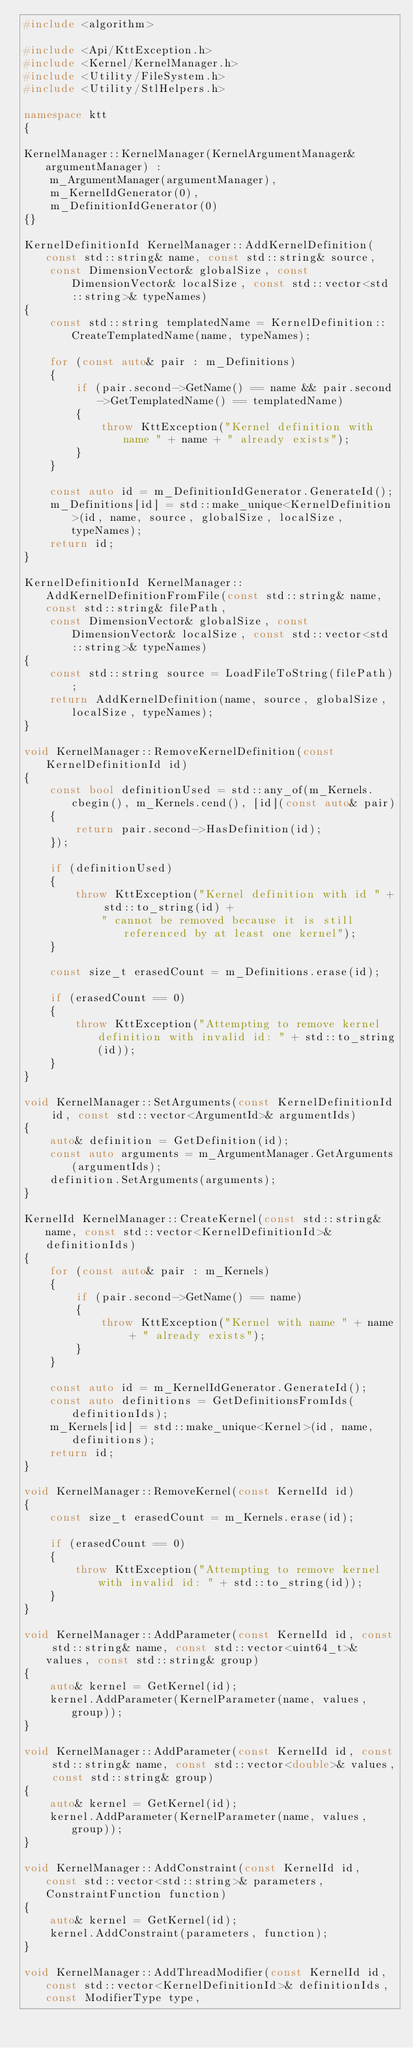Convert code to text. <code><loc_0><loc_0><loc_500><loc_500><_C++_>#include <algorithm>

#include <Api/KttException.h>
#include <Kernel/KernelManager.h>
#include <Utility/FileSystem.h>
#include <Utility/StlHelpers.h>

namespace ktt
{

KernelManager::KernelManager(KernelArgumentManager& argumentManager) :
    m_ArgumentManager(argumentManager),
    m_KernelIdGenerator(0),
    m_DefinitionIdGenerator(0)
{}

KernelDefinitionId KernelManager::AddKernelDefinition(const std::string& name, const std::string& source,
    const DimensionVector& globalSize, const DimensionVector& localSize, const std::vector<std::string>& typeNames)
{
    const std::string templatedName = KernelDefinition::CreateTemplatedName(name, typeNames);

    for (const auto& pair : m_Definitions)
    {
        if (pair.second->GetName() == name && pair.second->GetTemplatedName() == templatedName)
        {
            throw KttException("Kernel definition with name " + name + " already exists");
        }
    }

    const auto id = m_DefinitionIdGenerator.GenerateId();
    m_Definitions[id] = std::make_unique<KernelDefinition>(id, name, source, globalSize, localSize, typeNames);
    return id;
}

KernelDefinitionId KernelManager::AddKernelDefinitionFromFile(const std::string& name, const std::string& filePath,
    const DimensionVector& globalSize, const DimensionVector& localSize, const std::vector<std::string>& typeNames)
{
    const std::string source = LoadFileToString(filePath);
    return AddKernelDefinition(name, source, globalSize, localSize, typeNames);
}

void KernelManager::RemoveKernelDefinition(const KernelDefinitionId id)
{
    const bool definitionUsed = std::any_of(m_Kernels.cbegin(), m_Kernels.cend(), [id](const auto& pair)
    {
        return pair.second->HasDefinition(id);
    });

    if (definitionUsed)
    {
        throw KttException("Kernel definition with id " + std::to_string(id) +
            " cannot be removed because it is still referenced by at least one kernel");
    }

    const size_t erasedCount = m_Definitions.erase(id);

    if (erasedCount == 0)
    {
        throw KttException("Attempting to remove kernel definition with invalid id: " + std::to_string(id));
    }
}

void KernelManager::SetArguments(const KernelDefinitionId id, const std::vector<ArgumentId>& argumentIds)
{
    auto& definition = GetDefinition(id);
    const auto arguments = m_ArgumentManager.GetArguments(argumentIds);
    definition.SetArguments(arguments);
}

KernelId KernelManager::CreateKernel(const std::string& name, const std::vector<KernelDefinitionId>& definitionIds)
{
    for (const auto& pair : m_Kernels)
    {
        if (pair.second->GetName() == name)
        {
            throw KttException("Kernel with name " + name + " already exists");
        }
    }

    const auto id = m_KernelIdGenerator.GenerateId();
    const auto definitions = GetDefinitionsFromIds(definitionIds);
    m_Kernels[id] = std::make_unique<Kernel>(id, name, definitions);
    return id;
}

void KernelManager::RemoveKernel(const KernelId id)
{
    const size_t erasedCount = m_Kernels.erase(id);

    if (erasedCount == 0)
    {
        throw KttException("Attempting to remove kernel with invalid id: " + std::to_string(id));
    }
}

void KernelManager::AddParameter(const KernelId id, const std::string& name, const std::vector<uint64_t>& values, const std::string& group)
{
    auto& kernel = GetKernel(id);
    kernel.AddParameter(KernelParameter(name, values, group));
}

void KernelManager::AddParameter(const KernelId id, const std::string& name, const std::vector<double>& values, const std::string& group)
{
    auto& kernel = GetKernel(id);
    kernel.AddParameter(KernelParameter(name, values, group));
}

void KernelManager::AddConstraint(const KernelId id, const std::vector<std::string>& parameters, ConstraintFunction function)
{
    auto& kernel = GetKernel(id);
    kernel.AddConstraint(parameters, function);
}

void KernelManager::AddThreadModifier(const KernelId id, const std::vector<KernelDefinitionId>& definitionIds, const ModifierType type,</code> 